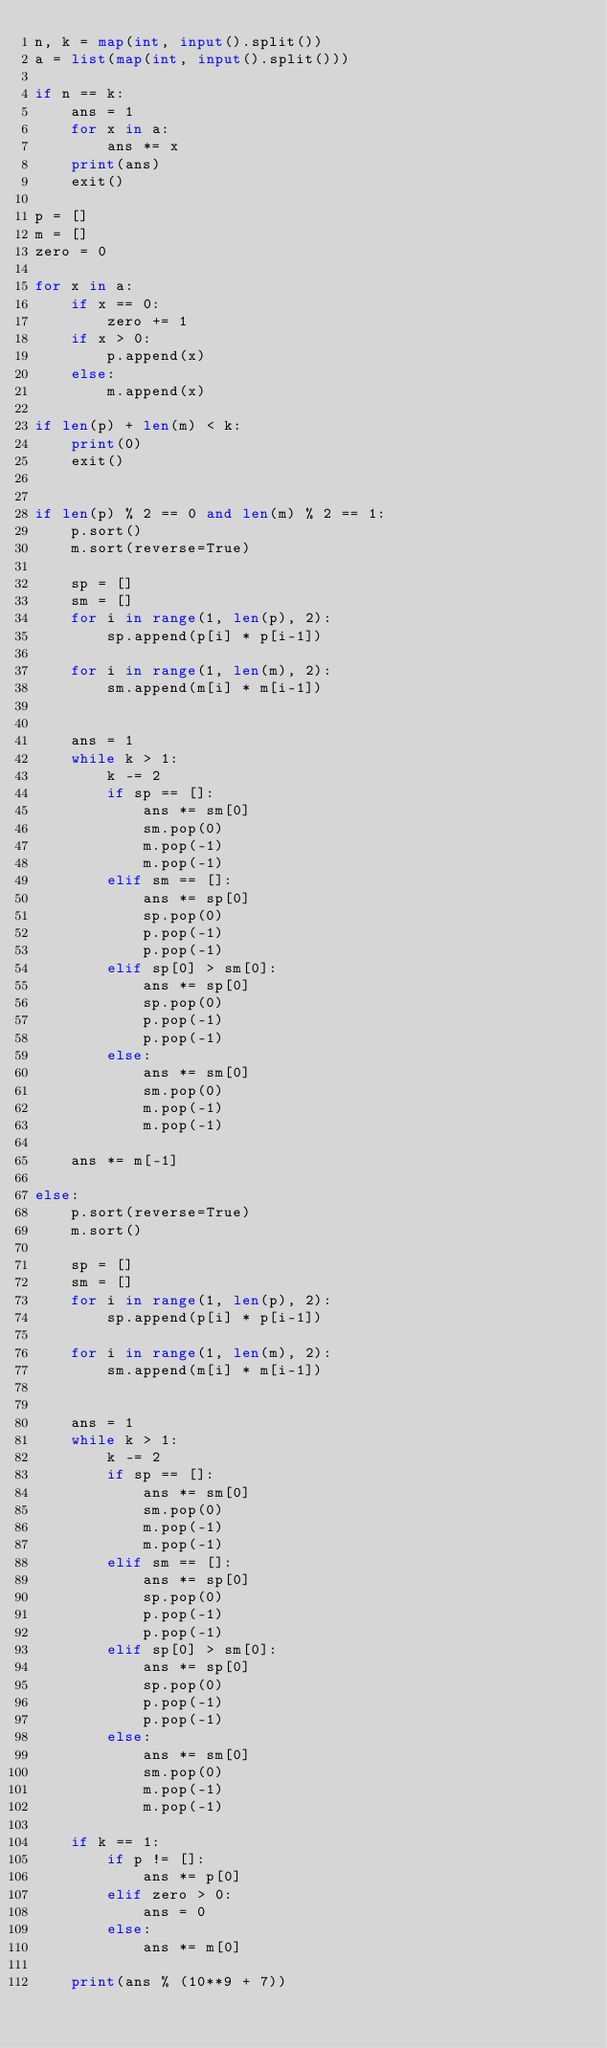Convert code to text. <code><loc_0><loc_0><loc_500><loc_500><_Python_>n, k = map(int, input().split())
a = list(map(int, input().split()))

if n == k:
    ans = 1
    for x in a:
        ans *= x
    print(ans)
    exit()

p = []
m = []
zero = 0

for x in a:
    if x == 0:
        zero += 1
    if x > 0:
        p.append(x)
    else:
        m.append(x)

if len(p) + len(m) < k:
    print(0)
    exit()


if len(p) % 2 == 0 and len(m) % 2 == 1: 
    p.sort()
    m.sort(reverse=True)
    
    sp = []
    sm = []
    for i in range(1, len(p), 2):
        sp.append(p[i] * p[i-1])
    
    for i in range(1, len(m), 2):
        sm.append(m[i] * m[i-1])
    
    
    ans = 1
    while k > 1:
        k -= 2
        if sp == []:
            ans *= sm[0]
            sm.pop(0)
            m.pop(-1)
            m.pop(-1)
        elif sm == []:
            ans *= sp[0]
            sp.pop(0)
            p.pop(-1)
            p.pop(-1)
        elif sp[0] > sm[0]:
            ans *= sp[0]
            sp.pop(0)
            p.pop(-1)
            p.pop(-1)
        else:
            ans *= sm[0]
            sm.pop(0)
            m.pop(-1)
            m.pop(-1)
    
    ans *= m[-1]

else: 
    p.sort(reverse=True)
    m.sort()
    
    sp = []
    sm = []
    for i in range(1, len(p), 2):
        sp.append(p[i] * p[i-1])
    
    for i in range(1, len(m), 2):
        sm.append(m[i] * m[i-1])
    
    
    ans = 1
    while k > 1:
        k -= 2
        if sp == []:
            ans *= sm[0]
            sm.pop(0)
            m.pop(-1)
            m.pop(-1)
        elif sm == []:
            ans *= sp[0]
            sp.pop(0)
            p.pop(-1)
            p.pop(-1)
        elif sp[0] > sm[0]:
            ans *= sp[0]
            sp.pop(0)
            p.pop(-1)
            p.pop(-1)
        else:
            ans *= sm[0]
            sm.pop(0)
            m.pop(-1)
            m.pop(-1)
    
    if k == 1:
        if p != []:
            ans *= p[0]
        elif zero > 0:
            ans = 0
        else:
            ans *= m[0]
    
    print(ans % (10**9 + 7))

</code> 